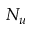<formula> <loc_0><loc_0><loc_500><loc_500>N _ { u }</formula> 